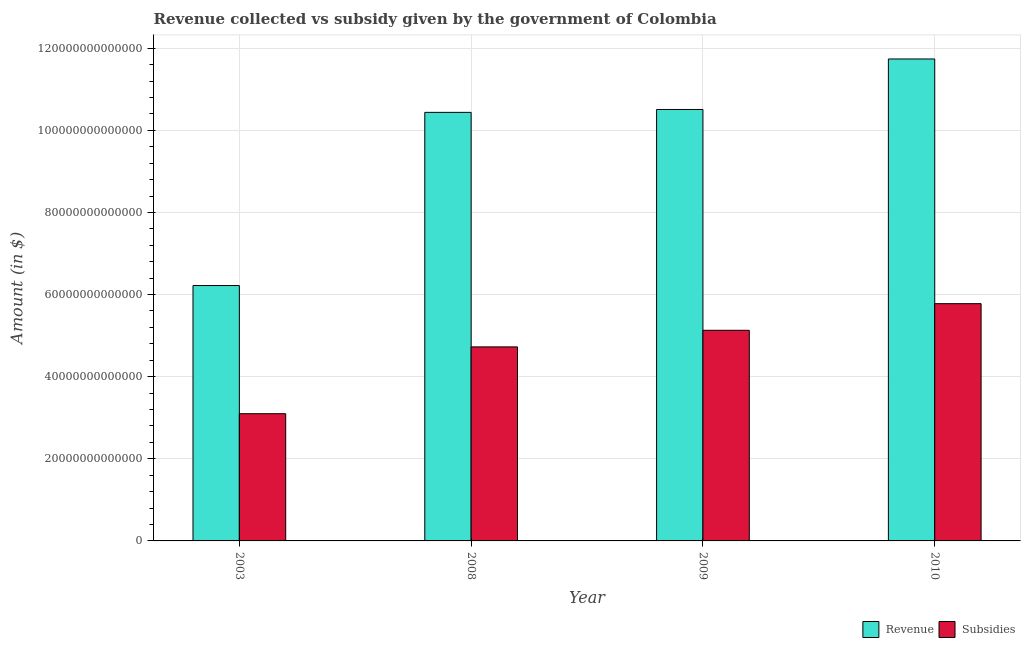How many different coloured bars are there?
Ensure brevity in your answer.  2. How many groups of bars are there?
Give a very brief answer. 4. Are the number of bars per tick equal to the number of legend labels?
Give a very brief answer. Yes. How many bars are there on the 1st tick from the left?
Your answer should be compact. 2. What is the label of the 1st group of bars from the left?
Your answer should be compact. 2003. What is the amount of revenue collected in 2010?
Offer a terse response. 1.17e+14. Across all years, what is the maximum amount of revenue collected?
Offer a very short reply. 1.17e+14. Across all years, what is the minimum amount of subsidies given?
Your answer should be compact. 3.10e+13. In which year was the amount of subsidies given minimum?
Offer a very short reply. 2003. What is the total amount of subsidies given in the graph?
Your answer should be compact. 1.87e+14. What is the difference between the amount of revenue collected in 2008 and that in 2009?
Offer a very short reply. -7.04e+11. What is the difference between the amount of subsidies given in 2008 and the amount of revenue collected in 2010?
Ensure brevity in your answer.  -1.05e+13. What is the average amount of subsidies given per year?
Offer a very short reply. 4.68e+13. In how many years, is the amount of revenue collected greater than 116000000000000 $?
Your response must be concise. 1. What is the ratio of the amount of subsidies given in 2003 to that in 2009?
Make the answer very short. 0.6. Is the amount of subsidies given in 2008 less than that in 2010?
Provide a succinct answer. Yes. Is the difference between the amount of revenue collected in 2009 and 2010 greater than the difference between the amount of subsidies given in 2009 and 2010?
Make the answer very short. No. What is the difference between the highest and the second highest amount of revenue collected?
Offer a very short reply. 1.23e+13. What is the difference between the highest and the lowest amount of subsidies given?
Keep it short and to the point. 2.68e+13. In how many years, is the amount of revenue collected greater than the average amount of revenue collected taken over all years?
Your response must be concise. 3. Is the sum of the amount of subsidies given in 2003 and 2009 greater than the maximum amount of revenue collected across all years?
Provide a short and direct response. Yes. What does the 2nd bar from the left in 2003 represents?
Offer a very short reply. Subsidies. What does the 2nd bar from the right in 2008 represents?
Your answer should be compact. Revenue. Are all the bars in the graph horizontal?
Give a very brief answer. No. What is the difference between two consecutive major ticks on the Y-axis?
Your answer should be compact. 2.00e+13. Where does the legend appear in the graph?
Ensure brevity in your answer.  Bottom right. What is the title of the graph?
Provide a succinct answer. Revenue collected vs subsidy given by the government of Colombia. Does "Electricity" appear as one of the legend labels in the graph?
Keep it short and to the point. No. What is the label or title of the X-axis?
Offer a very short reply. Year. What is the label or title of the Y-axis?
Offer a very short reply. Amount (in $). What is the Amount (in $) in Revenue in 2003?
Offer a very short reply. 6.22e+13. What is the Amount (in $) of Subsidies in 2003?
Your answer should be compact. 3.10e+13. What is the Amount (in $) in Revenue in 2008?
Your answer should be compact. 1.04e+14. What is the Amount (in $) in Subsidies in 2008?
Make the answer very short. 4.73e+13. What is the Amount (in $) of Revenue in 2009?
Your response must be concise. 1.05e+14. What is the Amount (in $) in Subsidies in 2009?
Offer a terse response. 5.13e+13. What is the Amount (in $) of Revenue in 2010?
Offer a very short reply. 1.17e+14. What is the Amount (in $) in Subsidies in 2010?
Keep it short and to the point. 5.78e+13. Across all years, what is the maximum Amount (in $) in Revenue?
Ensure brevity in your answer.  1.17e+14. Across all years, what is the maximum Amount (in $) in Subsidies?
Offer a terse response. 5.78e+13. Across all years, what is the minimum Amount (in $) in Revenue?
Provide a short and direct response. 6.22e+13. Across all years, what is the minimum Amount (in $) of Subsidies?
Provide a short and direct response. 3.10e+13. What is the total Amount (in $) in Revenue in the graph?
Provide a short and direct response. 3.89e+14. What is the total Amount (in $) of Subsidies in the graph?
Make the answer very short. 1.87e+14. What is the difference between the Amount (in $) in Revenue in 2003 and that in 2008?
Ensure brevity in your answer.  -4.22e+13. What is the difference between the Amount (in $) of Subsidies in 2003 and that in 2008?
Offer a very short reply. -1.63e+13. What is the difference between the Amount (in $) of Revenue in 2003 and that in 2009?
Make the answer very short. -4.29e+13. What is the difference between the Amount (in $) of Subsidies in 2003 and that in 2009?
Your response must be concise. -2.03e+13. What is the difference between the Amount (in $) in Revenue in 2003 and that in 2010?
Provide a short and direct response. -5.52e+13. What is the difference between the Amount (in $) of Subsidies in 2003 and that in 2010?
Offer a very short reply. -2.68e+13. What is the difference between the Amount (in $) in Revenue in 2008 and that in 2009?
Offer a very short reply. -7.04e+11. What is the difference between the Amount (in $) of Subsidies in 2008 and that in 2009?
Provide a succinct answer. -4.04e+12. What is the difference between the Amount (in $) of Revenue in 2008 and that in 2010?
Offer a terse response. -1.30e+13. What is the difference between the Amount (in $) of Subsidies in 2008 and that in 2010?
Offer a very short reply. -1.05e+13. What is the difference between the Amount (in $) of Revenue in 2009 and that in 2010?
Ensure brevity in your answer.  -1.23e+13. What is the difference between the Amount (in $) of Subsidies in 2009 and that in 2010?
Provide a short and direct response. -6.49e+12. What is the difference between the Amount (in $) of Revenue in 2003 and the Amount (in $) of Subsidies in 2008?
Ensure brevity in your answer.  1.49e+13. What is the difference between the Amount (in $) in Revenue in 2003 and the Amount (in $) in Subsidies in 2009?
Give a very brief answer. 1.09e+13. What is the difference between the Amount (in $) of Revenue in 2003 and the Amount (in $) of Subsidies in 2010?
Provide a succinct answer. 4.42e+12. What is the difference between the Amount (in $) in Revenue in 2008 and the Amount (in $) in Subsidies in 2009?
Keep it short and to the point. 5.31e+13. What is the difference between the Amount (in $) of Revenue in 2008 and the Amount (in $) of Subsidies in 2010?
Provide a short and direct response. 4.66e+13. What is the difference between the Amount (in $) of Revenue in 2009 and the Amount (in $) of Subsidies in 2010?
Provide a succinct answer. 4.73e+13. What is the average Amount (in $) in Revenue per year?
Offer a terse response. 9.73e+13. What is the average Amount (in $) of Subsidies per year?
Keep it short and to the point. 4.68e+13. In the year 2003, what is the difference between the Amount (in $) in Revenue and Amount (in $) in Subsidies?
Give a very brief answer. 3.12e+13. In the year 2008, what is the difference between the Amount (in $) in Revenue and Amount (in $) in Subsidies?
Your response must be concise. 5.71e+13. In the year 2009, what is the difference between the Amount (in $) in Revenue and Amount (in $) in Subsidies?
Your answer should be compact. 5.38e+13. In the year 2010, what is the difference between the Amount (in $) in Revenue and Amount (in $) in Subsidies?
Give a very brief answer. 5.96e+13. What is the ratio of the Amount (in $) in Revenue in 2003 to that in 2008?
Offer a terse response. 0.6. What is the ratio of the Amount (in $) of Subsidies in 2003 to that in 2008?
Provide a succinct answer. 0.66. What is the ratio of the Amount (in $) of Revenue in 2003 to that in 2009?
Keep it short and to the point. 0.59. What is the ratio of the Amount (in $) in Subsidies in 2003 to that in 2009?
Keep it short and to the point. 0.6. What is the ratio of the Amount (in $) in Revenue in 2003 to that in 2010?
Your answer should be very brief. 0.53. What is the ratio of the Amount (in $) in Subsidies in 2003 to that in 2010?
Your answer should be compact. 0.54. What is the ratio of the Amount (in $) of Revenue in 2008 to that in 2009?
Offer a very short reply. 0.99. What is the ratio of the Amount (in $) of Subsidies in 2008 to that in 2009?
Give a very brief answer. 0.92. What is the ratio of the Amount (in $) in Revenue in 2008 to that in 2010?
Your answer should be very brief. 0.89. What is the ratio of the Amount (in $) in Subsidies in 2008 to that in 2010?
Offer a very short reply. 0.82. What is the ratio of the Amount (in $) in Revenue in 2009 to that in 2010?
Your response must be concise. 0.9. What is the ratio of the Amount (in $) of Subsidies in 2009 to that in 2010?
Ensure brevity in your answer.  0.89. What is the difference between the highest and the second highest Amount (in $) of Revenue?
Your response must be concise. 1.23e+13. What is the difference between the highest and the second highest Amount (in $) in Subsidies?
Ensure brevity in your answer.  6.49e+12. What is the difference between the highest and the lowest Amount (in $) in Revenue?
Your answer should be compact. 5.52e+13. What is the difference between the highest and the lowest Amount (in $) in Subsidies?
Offer a very short reply. 2.68e+13. 